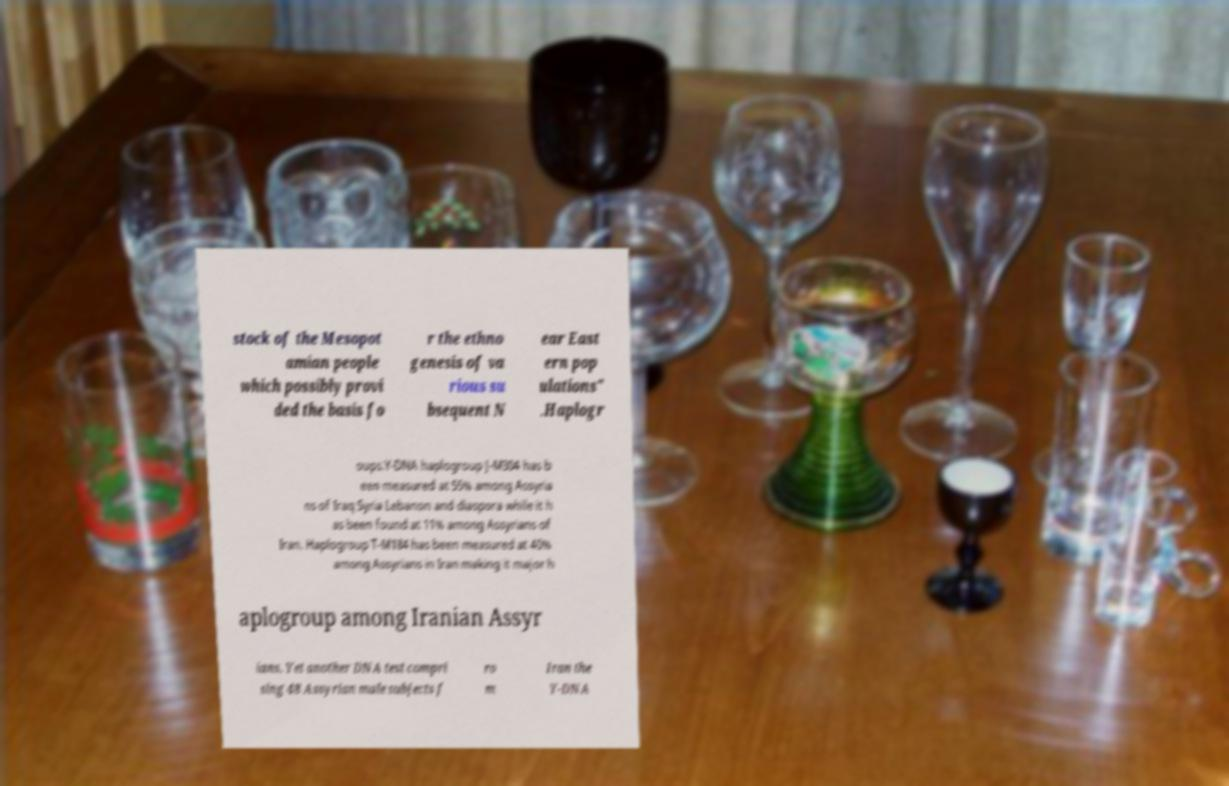Can you accurately transcribe the text from the provided image for me? stock of the Mesopot amian people which possibly provi ded the basis fo r the ethno genesis of va rious su bsequent N ear East ern pop ulations" .Haplogr oups.Y-DNA haplogroup J-M304 has b een measured at 55% among Assyria ns of Iraq Syria Lebanon and diaspora while it h as been found at 11% among Assyrians of Iran. Haplogroup T-M184 has been measured at 40% among Assyrians in Iran making it major h aplogroup among Iranian Assyr ians. Yet another DNA test compri sing 48 Assyrian male subjects f ro m Iran the Y-DNA 